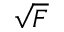Convert formula to latex. <formula><loc_0><loc_0><loc_500><loc_500>\sqrt { F }</formula> 